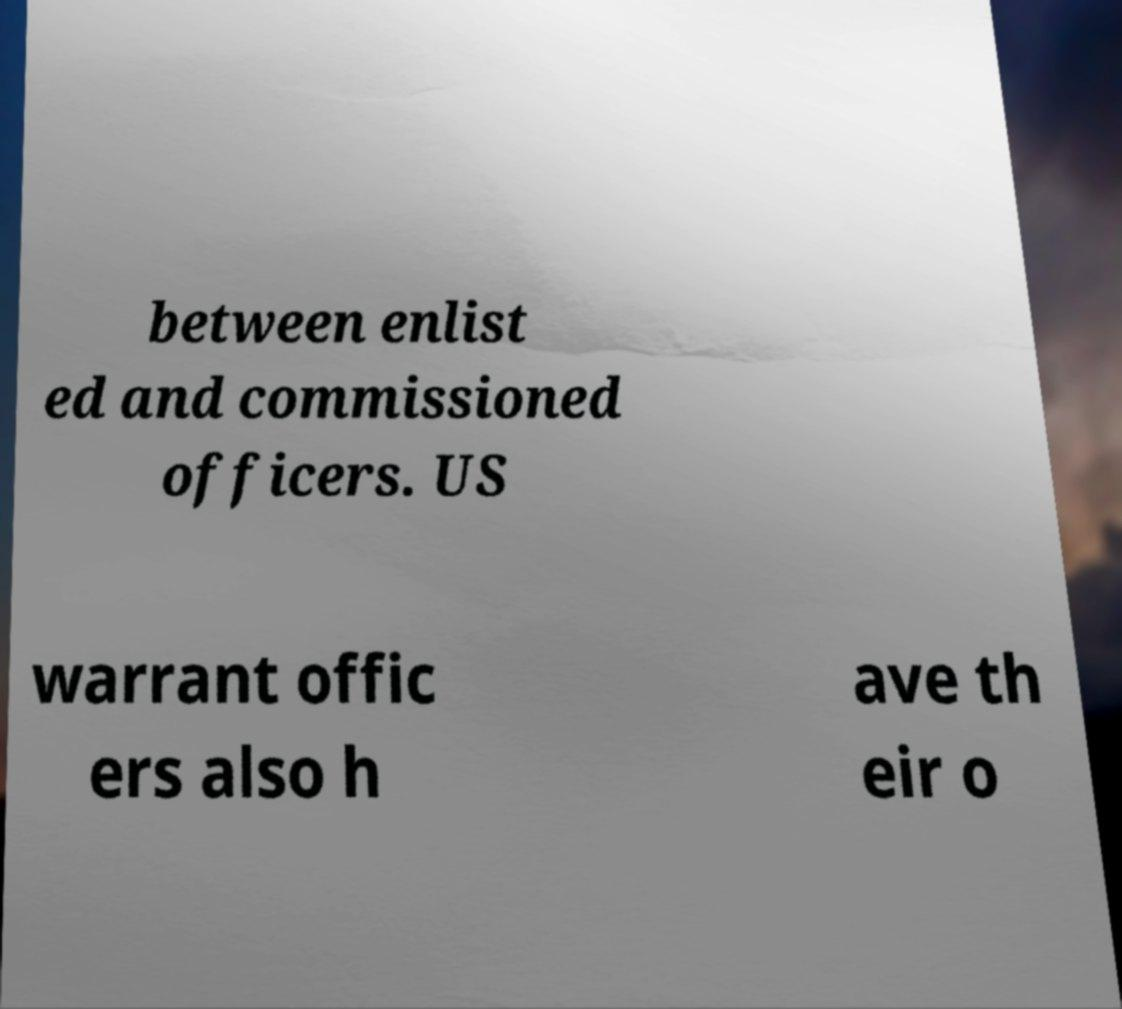Can you accurately transcribe the text from the provided image for me? between enlist ed and commissioned officers. US warrant offic ers also h ave th eir o 